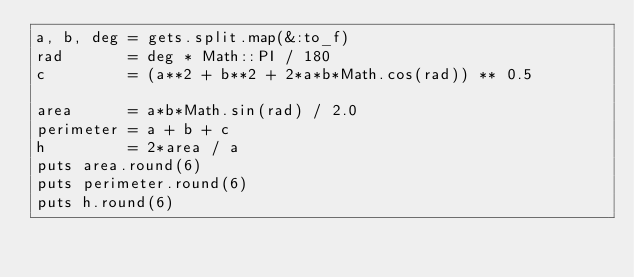Convert code to text. <code><loc_0><loc_0><loc_500><loc_500><_Ruby_>a, b, deg = gets.split.map(&:to_f)
rad       = deg * Math::PI / 180
c         = (a**2 + b**2 + 2*a*b*Math.cos(rad)) ** 0.5

area      = a*b*Math.sin(rad) / 2.0
perimeter = a + b + c
h         = 2*area / a
puts area.round(6)
puts perimeter.round(6)
puts h.round(6)</code> 